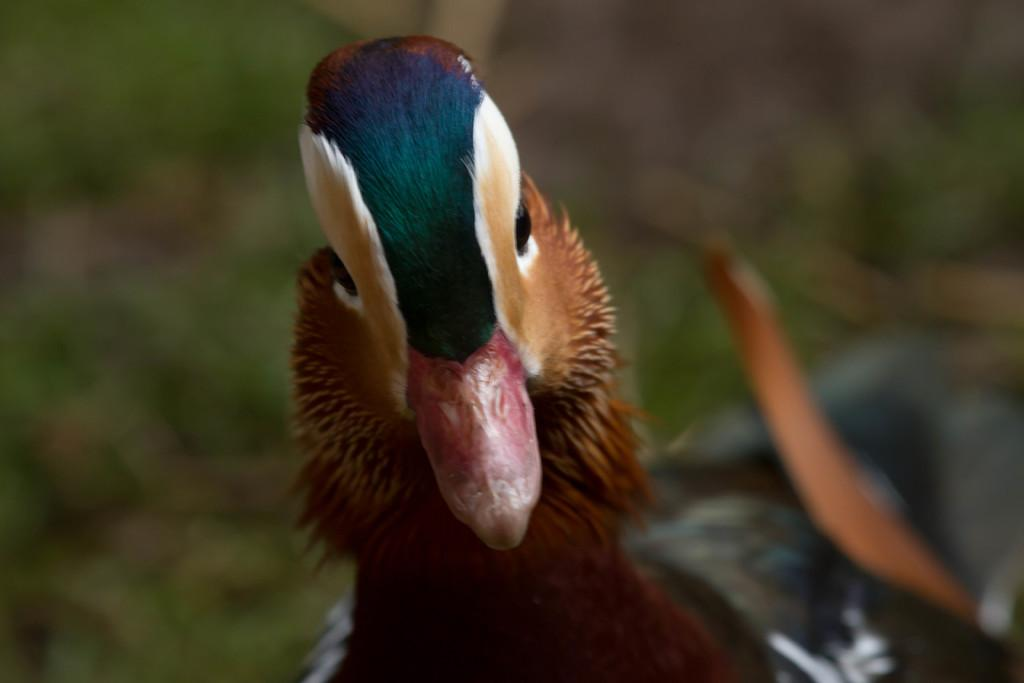What animal is present in the image? There is a duck in the image. Can you describe the background of the image? The background of the image is blurred. What is the monetary value of the duck in the image? There is no indication of the duck's monetary value in the image. What time of day is depicted in the image? The time of day is not discernible from the image. 